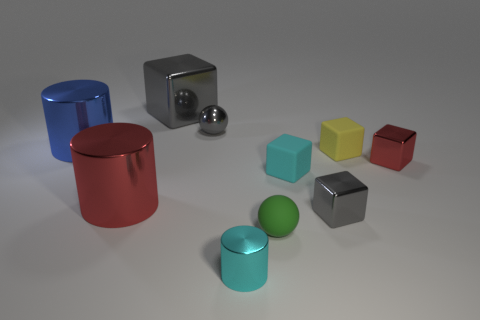Subtract all yellow matte blocks. How many blocks are left? 4 Subtract all cyan spheres. How many gray blocks are left? 2 Subtract all balls. How many objects are left? 8 Subtract all yellow cubes. How many cubes are left? 4 Subtract 1 balls. How many balls are left? 1 Subtract all gray blocks. Subtract all gray metallic objects. How many objects are left? 5 Add 2 blue cylinders. How many blue cylinders are left? 3 Add 4 yellow rubber balls. How many yellow rubber balls exist? 4 Subtract 0 brown spheres. How many objects are left? 10 Subtract all blue spheres. Subtract all yellow cubes. How many spheres are left? 2 